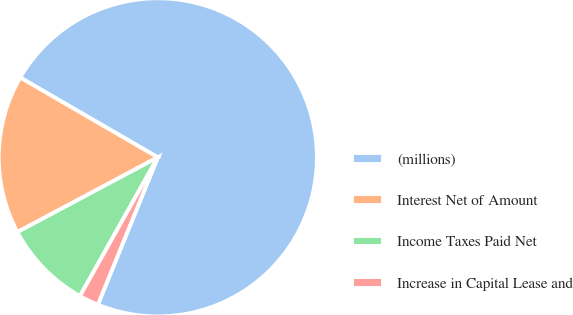<chart> <loc_0><loc_0><loc_500><loc_500><pie_chart><fcel>(millions)<fcel>Interest Net of Amount<fcel>Income Taxes Paid Net<fcel>Increase in Capital Lease and<nl><fcel>72.8%<fcel>16.15%<fcel>9.07%<fcel>1.99%<nl></chart> 